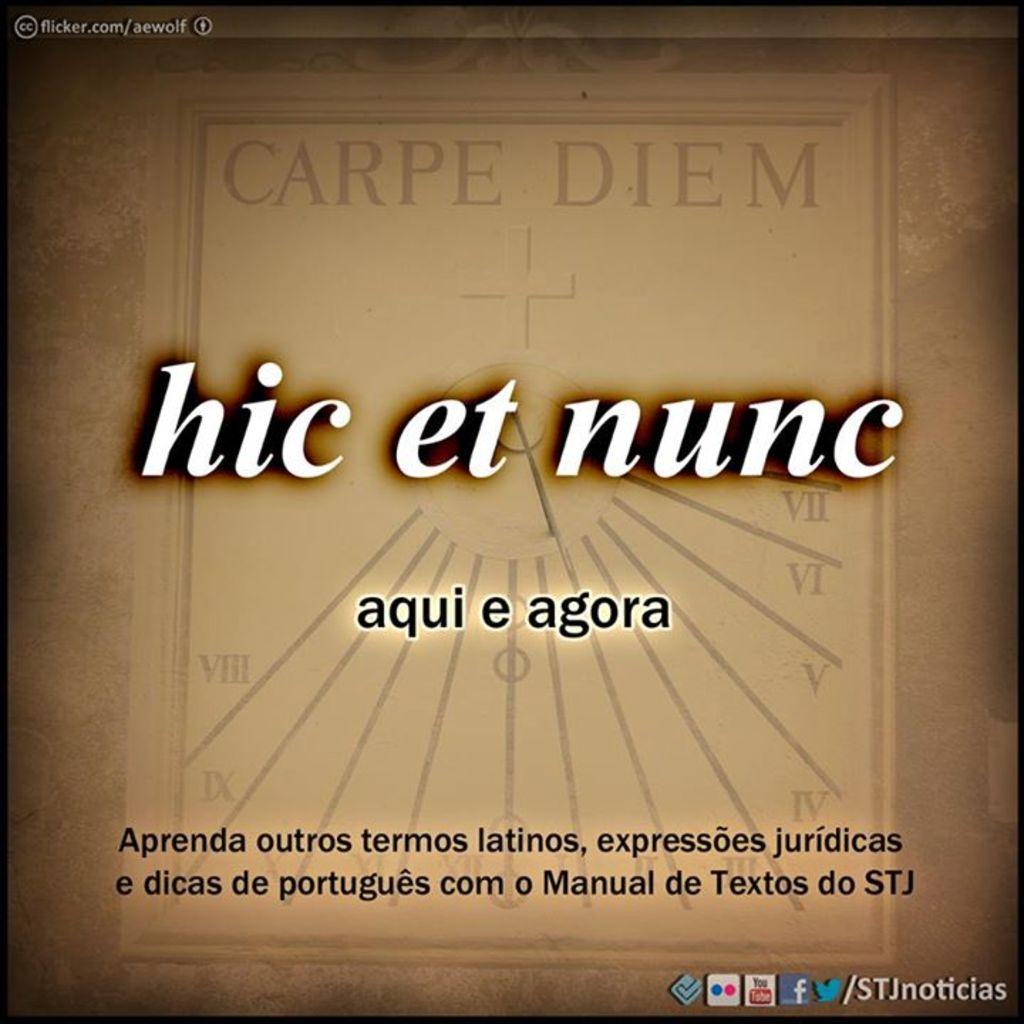Which number is expressed by the roman numeral on the far left?
Your response must be concise. 8. What is the website at the top left corner?
Give a very brief answer. Flicker.com/aewolf. 